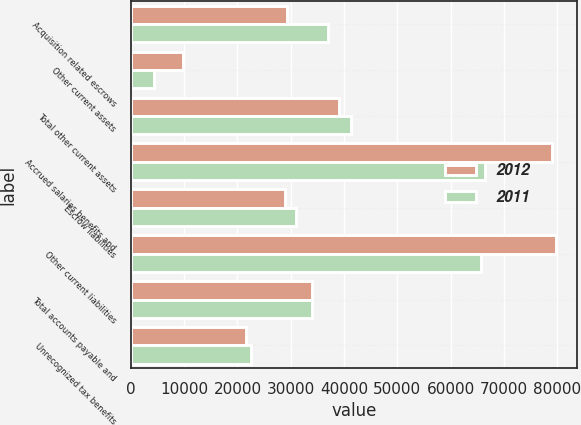Convert chart to OTSL. <chart><loc_0><loc_0><loc_500><loc_500><stacked_bar_chart><ecel><fcel>Acquisition related escrows<fcel>Other current assets<fcel>Total other current assets<fcel>Accrued salaries benefits and<fcel>Escrow liabilities<fcel>Other current liabilities<fcel>Total accounts payable and<fcel>Unrecognized tax benefits<nl><fcel>2012<fcel>29277<fcel>9832<fcel>39109<fcel>78979<fcel>28954<fcel>79715<fcel>33933<fcel>21611<nl><fcel>2011<fcel>36967<fcel>4281<fcel>41248<fcel>66354<fcel>30899<fcel>65739<fcel>33933<fcel>22567<nl></chart> 